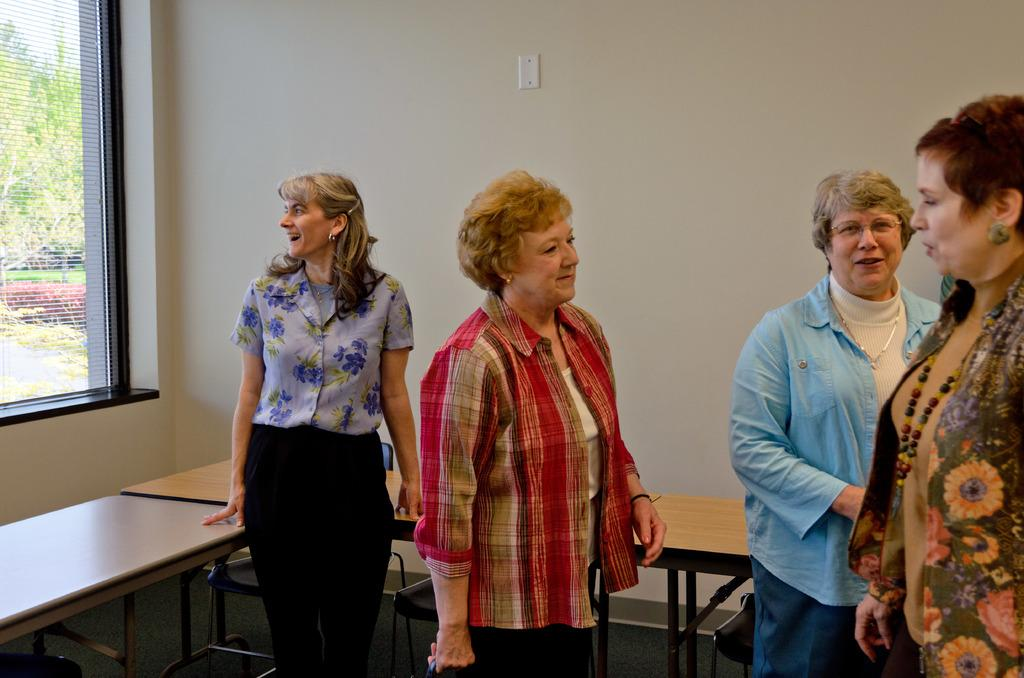How many women are present in the room? There are four women in the room. What are the women doing in the room? The women are talking to each other. What furniture can be seen in the room? There is a table in the room. What is visible in the background of the room? There is a wall in the background. Where is the window located in the room? The window is on the left side of the room. What type of muscle can be seen flexing in the image? There are no muscles visible in the image, as it features four women talking in a room. What sound do the bells make in the image? There are no bells present in the image. 